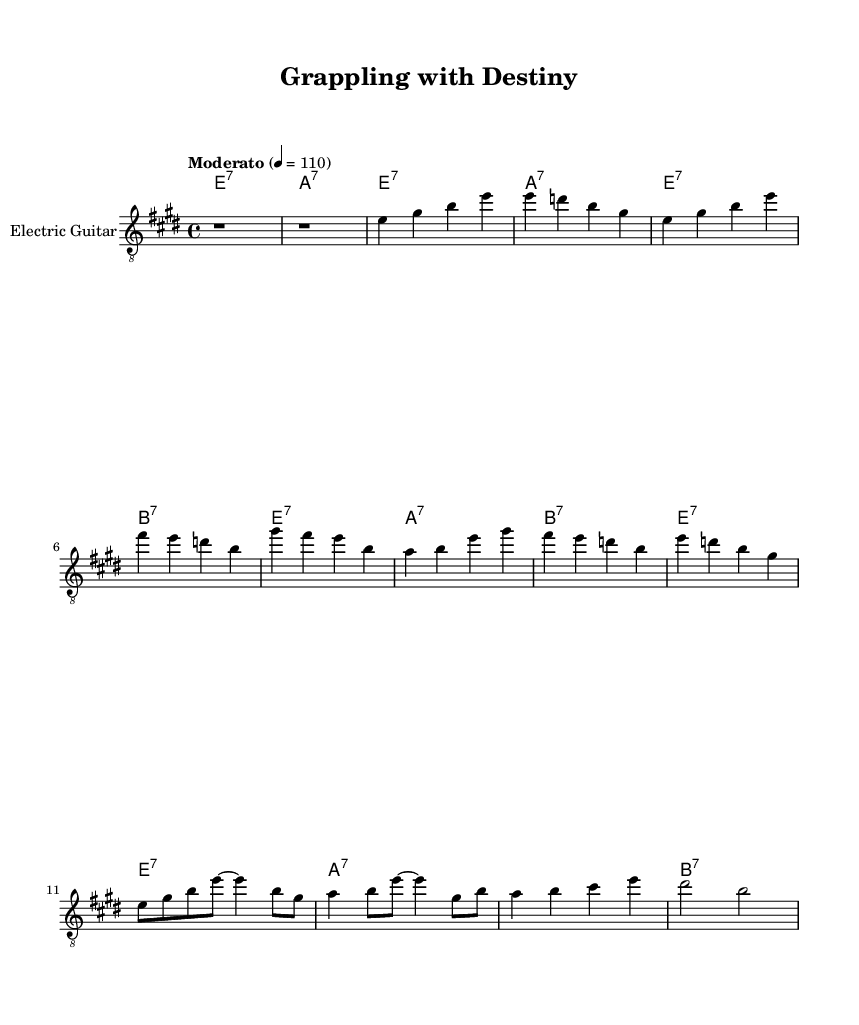What is the key signature of this music? The key signature is indicated in the global settings at the beginning of the music. It shows that the key is E major, which has four sharps.
Answer: E major What is the time signature of this music? The time signature is also found in the global settings. It states 4/4, meaning there are four beats in each measure, and the quarter note gets one beat.
Answer: 4/4 What is the tempo marking of this piece? The tempo is listed in the global section as "Moderato", with a beats per minute marking of 110. This indicates a moderate pace for the music.
Answer: Moderato How many measures are in the verse section? The verse consists of four measures as seen in the music notation. Each group of notes indicates one measure, and there are four distinct segments in the verse.
Answer: 4 What are the primary chords used in the chorus? The primary chords in the chorus can be identified in the chord names section where E, A, and B7 are repeated throughout the chorus, showing their importance in this section of the song.
Answer: E, A, B7 What is the time duration of the bridge section? The bridge includes two measures of music, as noted by the notation showing two sets of notes separated by line breaks. Each measure corresponds to one line segment.
Answer: 2 measures What style does this piece represent within the Blues genre? The piece is a Blues rock anthem because it combines traditional blues elements, such as the use of specific chord progressions (E7, A7, B7), with a rock tempo and instrumentation (electric guitar).
Answer: Blues rock anthem 